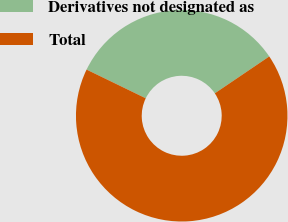<chart> <loc_0><loc_0><loc_500><loc_500><pie_chart><fcel>Derivatives not designated as<fcel>Total<nl><fcel>33.33%<fcel>66.67%<nl></chart> 